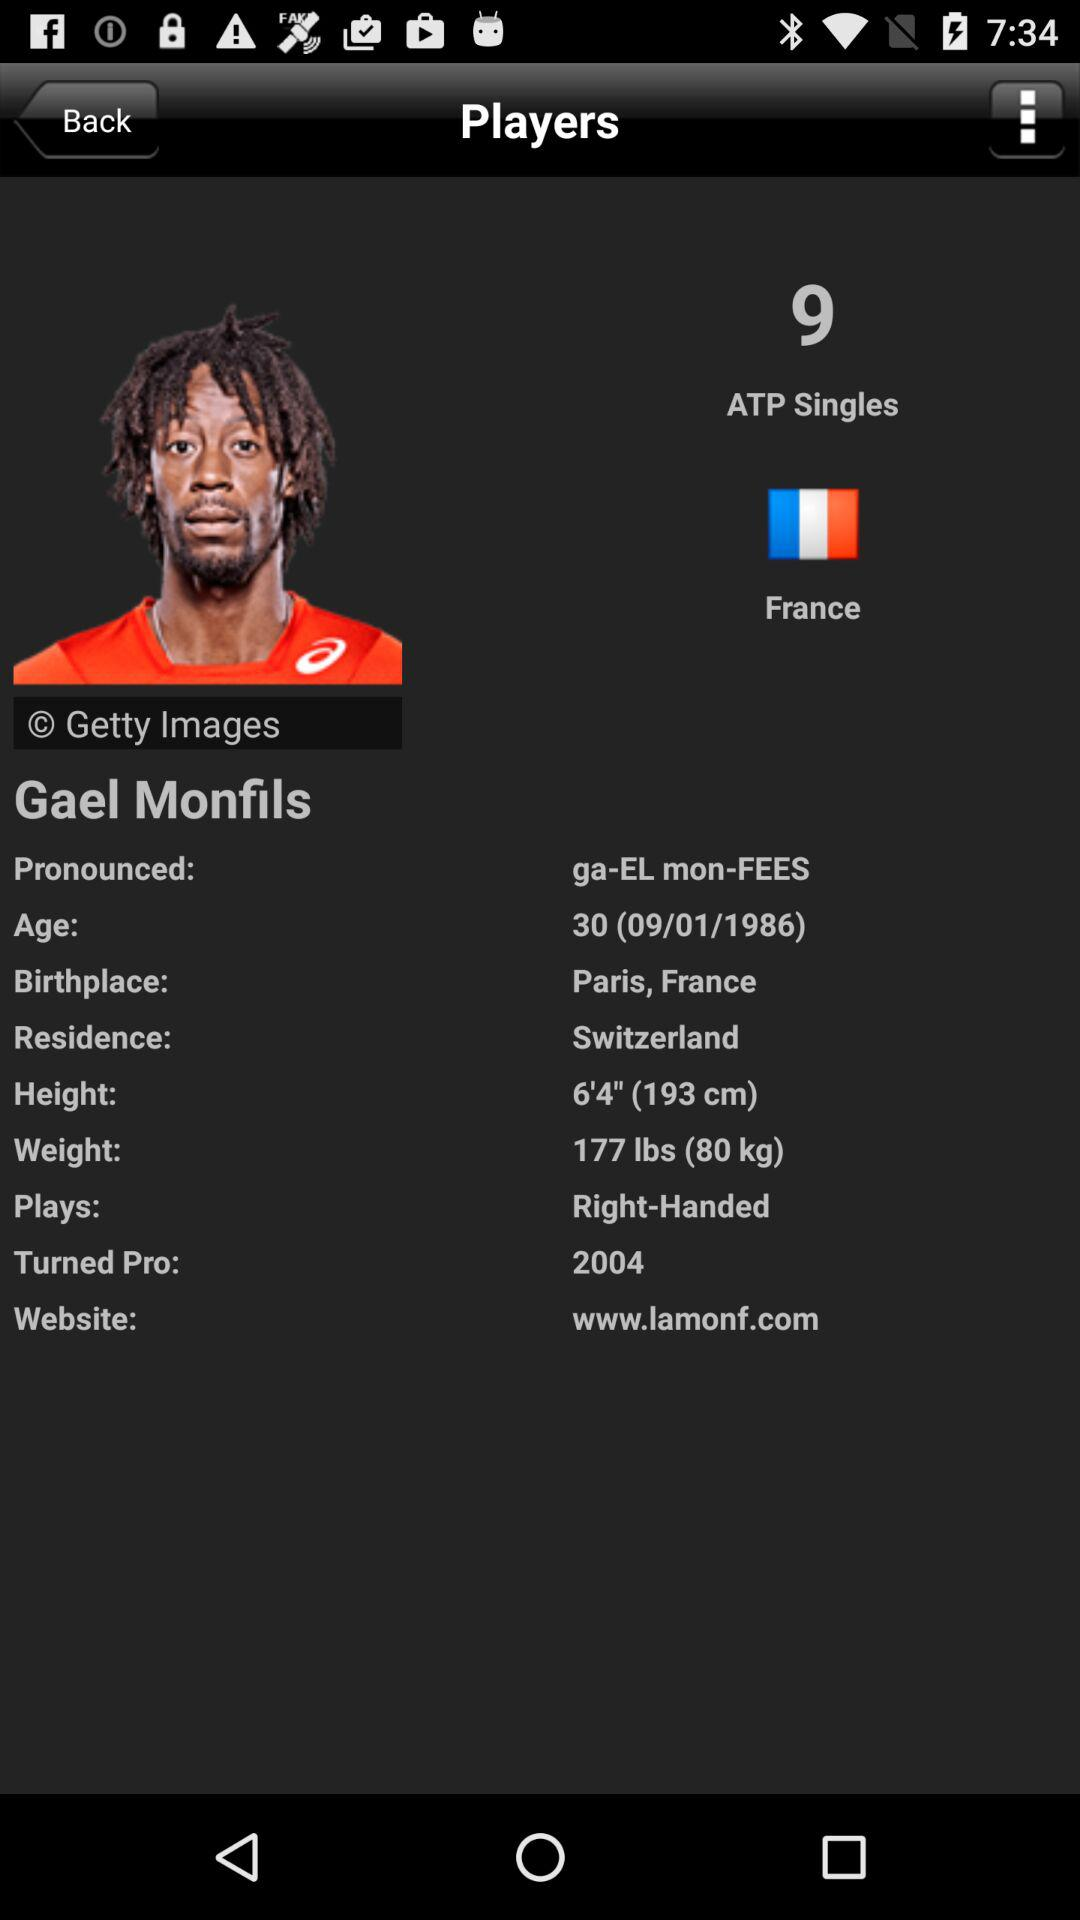What is the height of the player? The height of the player is 6'4" (193 cm). 